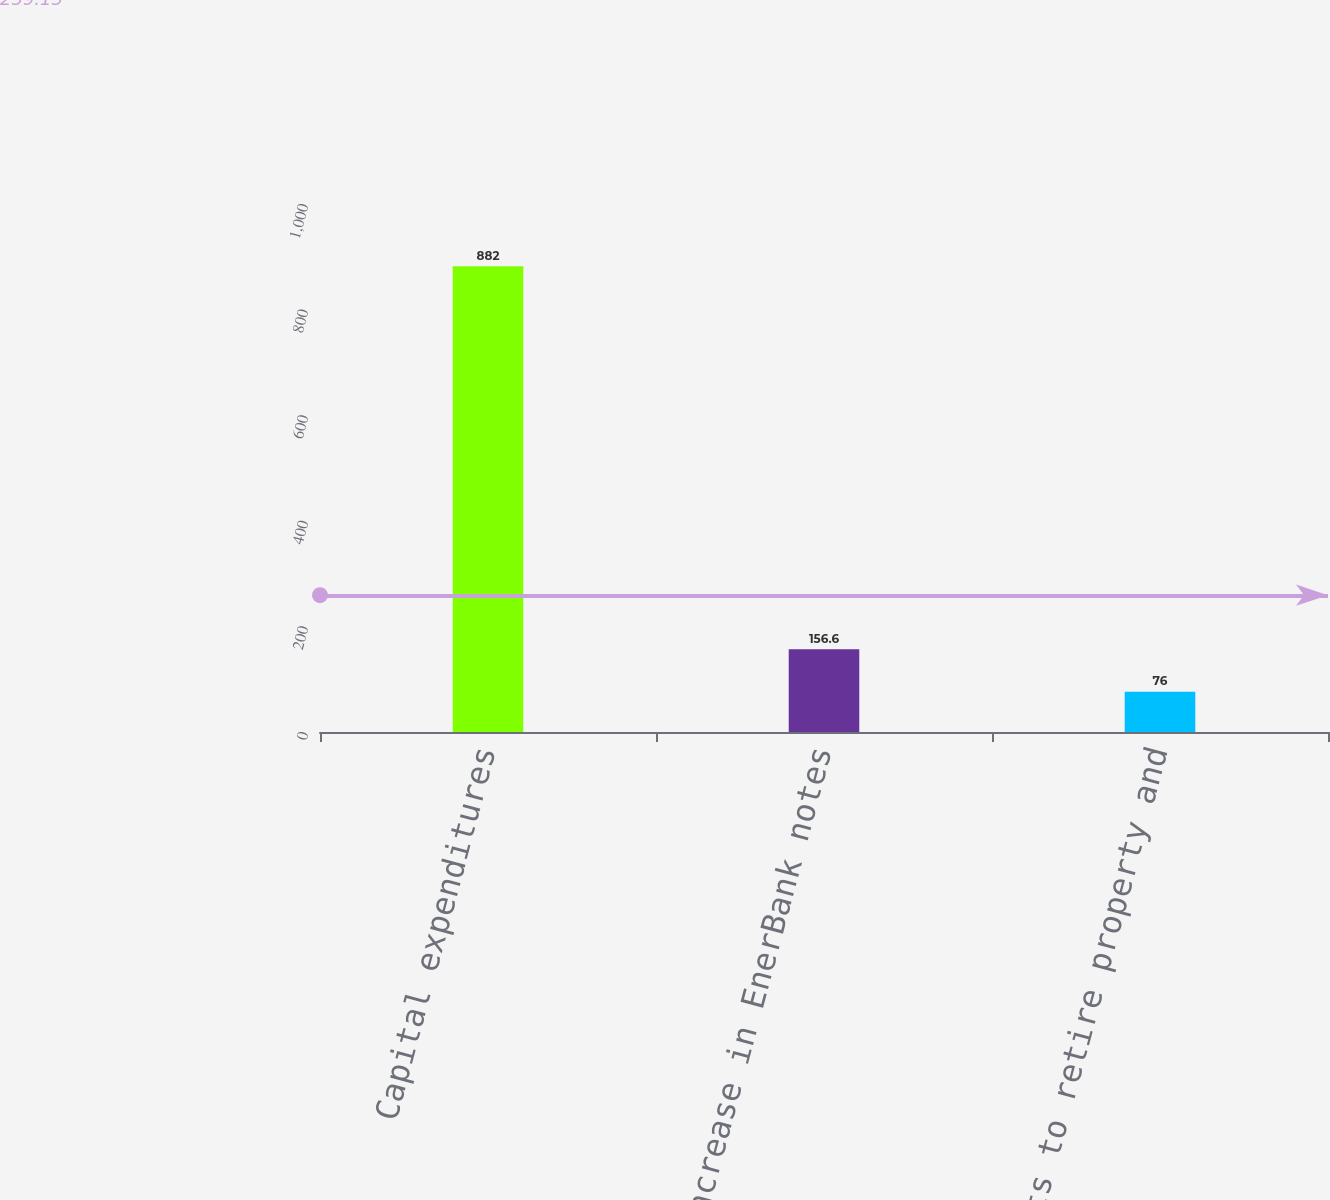Convert chart to OTSL. <chart><loc_0><loc_0><loc_500><loc_500><bar_chart><fcel>Capital expenditures<fcel>Increase in EnerBank notes<fcel>Costs to retire property and<nl><fcel>882<fcel>156.6<fcel>76<nl></chart> 